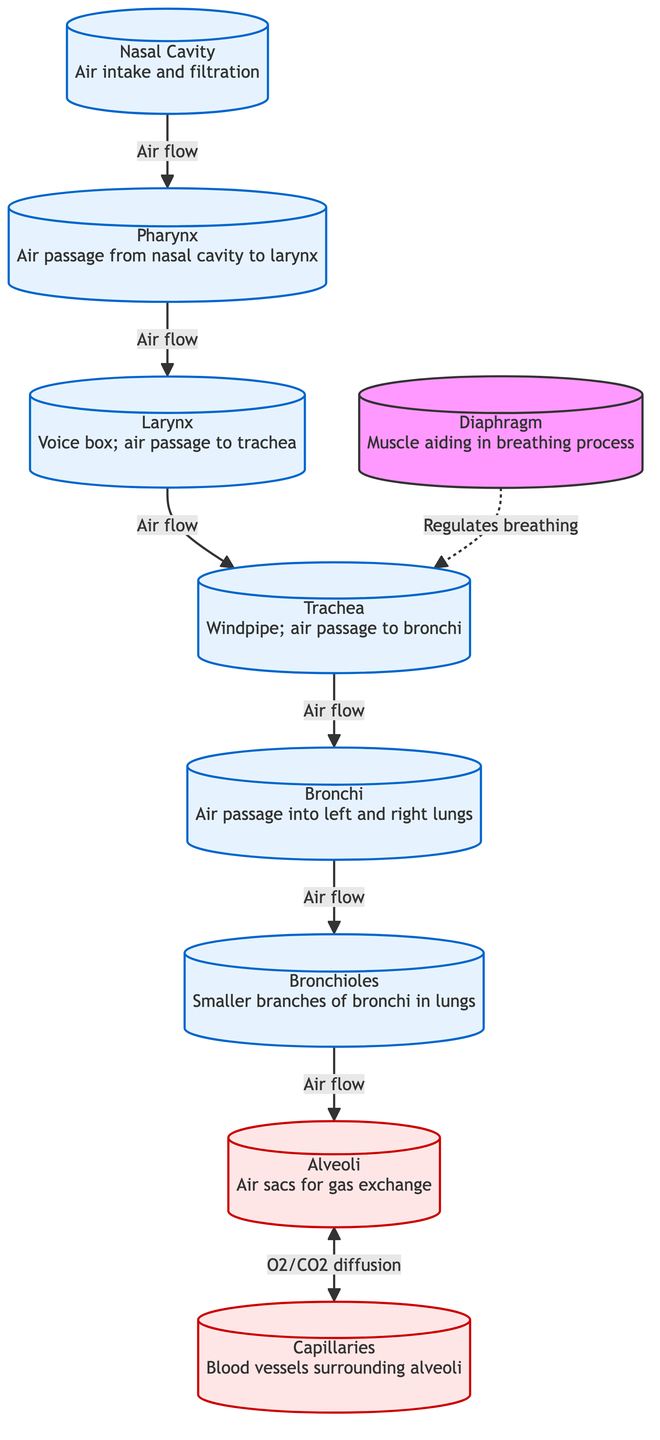What is the first step in the airflow process? The first node in the diagram is the Nasal Cavity, which indicates the initial point of air intake and filtration before it makes its way through the respiratory system.
Answer: Nasal Cavity How many structures are involved in airflow before reaching the alveoli? By following the air flow from the Nasal Cavity to the Alveoli, we identify a total of six structures (Nasal Cavity, Pharynx, Larynx, Trachea, Bronchi, and Bronchioles) that air passes through before reaching the alveoli.
Answer: Six What is the function of the alveoli? The diagram shows that the function of the alveoli is gas exchange, specifically the diffusion of Oxygen and Carbon Dioxide occurring between the alveoli and the surrounding capillaries.
Answer: Gas exchange Which structure potentially regulates the breathing process? Upon examining the roles outlined in the diagram, the Diaphragm is indicated to be a muscle that aids in the process of breathing and thus regulates it, especially in conjunction with the airflow to the trachea.
Answer: Diaphragm What type of vessels surround the alveoli? The diagram specifically labels the blood vessels that surround the alveoli as Capillaries, highlighting their role in the gas exchange process.
Answer: Capillaries What is the relationship between the alveoli and capillaries? The diagram shows a bidirectional flow of Oxygen and Carbon Dioxide between alveoli and capillaries, indicating a mutual exchange process happening during respiration.
Answer: O2/CO2 diffusion What comes after the trachea in the airflow pathway? From the diagram, after the Trachea, the next structure in the path of airflow is the Bronchi, which serves as the main air passage into each lung.
Answer: Bronchi In the overall respiratory system, which component is responsible for voice production? The diagram identifies the Larynx as the voice box, signifying its role in the respiratory system related to sound production and air passage.
Answer: Larynx 